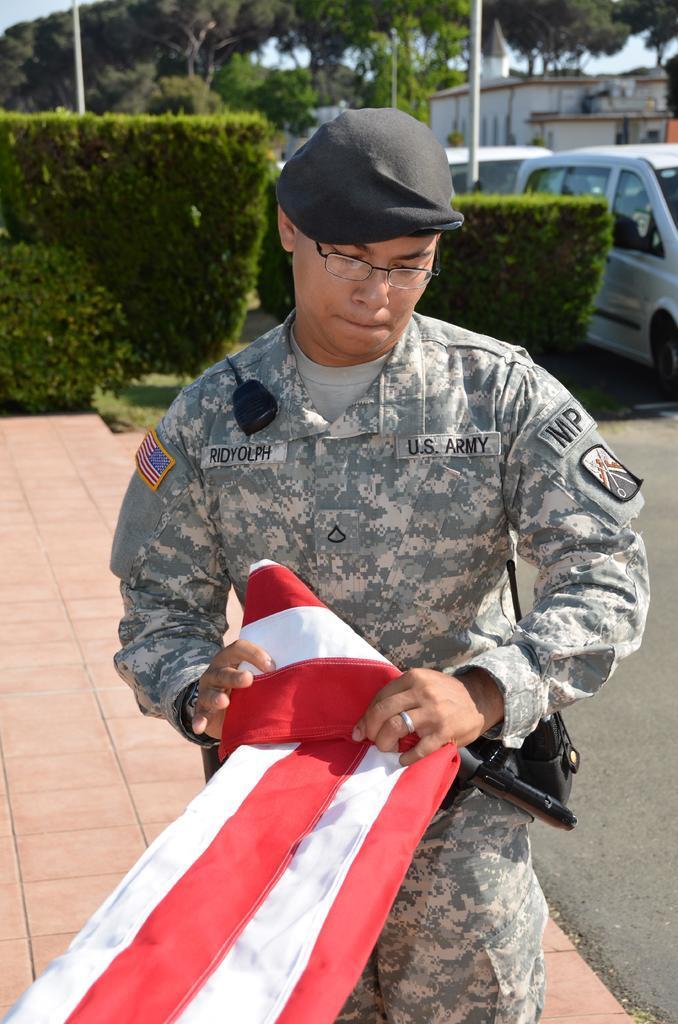Please provide a concise description of this image. In the center of the image we can see a person holding a flag. In the background there are trees, building, plants, cats, pole and sky. 